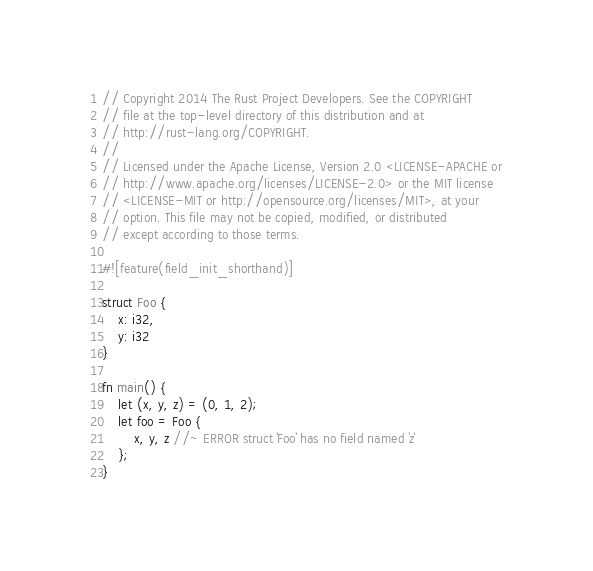<code> <loc_0><loc_0><loc_500><loc_500><_Rust_>// Copyright 2014 The Rust Project Developers. See the COPYRIGHT
// file at the top-level directory of this distribution and at
// http://rust-lang.org/COPYRIGHT.
//
// Licensed under the Apache License, Version 2.0 <LICENSE-APACHE or
// http://www.apache.org/licenses/LICENSE-2.0> or the MIT license
// <LICENSE-MIT or http://opensource.org/licenses/MIT>, at your
// option. This file may not be copied, modified, or distributed
// except according to those terms.

#![feature(field_init_shorthand)]

struct Foo {
    x: i32,
    y: i32
}

fn main() {
    let (x, y, z) = (0, 1, 2);
    let foo = Foo {
        x, y, z //~ ERROR struct `Foo` has no field named `z`
    };
}

</code> 